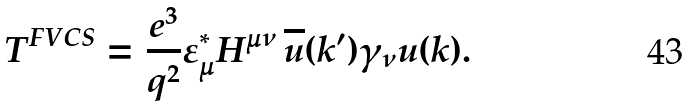<formula> <loc_0><loc_0><loc_500><loc_500>T ^ { F V C S } = \frac { e ^ { 3 } } { q ^ { 2 } } \varepsilon _ { \mu } ^ { * } H ^ { \mu \nu } \, \overline { u } ( k ^ { \prime } ) \gamma _ { \nu } u ( k ) .</formula> 